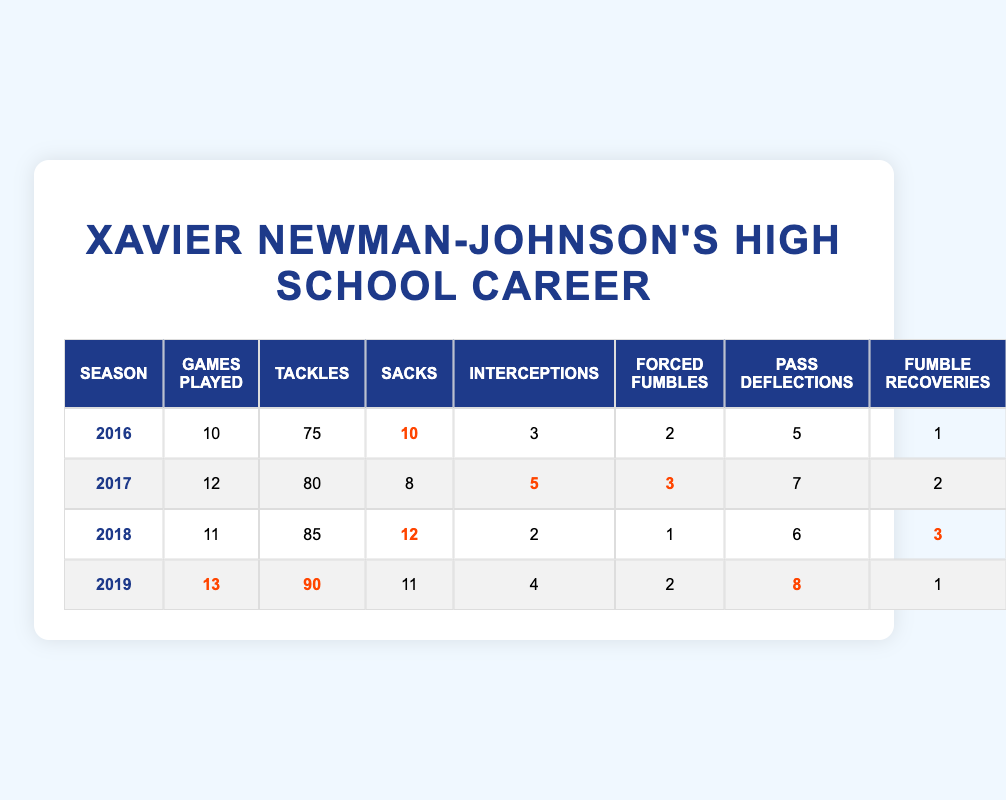What was Xavier Newman-Johnson's highest number of tackles in a season? In the table, we can see that the number of tackles varies by season. The highest value listed is 90 in the 2019 season.
Answer: 90 In which season did Xavier Newman-Johnson achieve the most sacks? By looking through the Sacks column, we note the maximum number is 12, which occurred during the 2018 season.
Answer: 2018 How many total interceptions did Xavier Newman-Johnson have over his high school career? To find the total interceptions, we add up the values from each season: 3 + 5 + 2 + 4 = 14.
Answer: 14 Did Xavier Newman-Johnson have more forced fumbles in 2017 compared to 2016? The data shows that he had 3 forced fumbles in 2017 and 2 in 2016. Therefore, he did have more in 2017.
Answer: Yes What was the average number of games played per season during Xavier Newman-Johnson's high school career? The total number of games played is 10 + 12 + 11 + 13 = 46. There are 4 seasons, so the average is 46 / 4 = 11.5.
Answer: 11.5 Which season had the highest number of fumble recoveries? In the Fumble Recoveries column, we can see the values are 1, 2, 3, and 1 for each respective season. The highest recorded is 3 in 2018.
Answer: 2018 How many more pass deflections did Xavier Newman-Johnson achieve in his best season compared to his worst? The best season for pass deflections was 8 in 2019, and the worst was 5 in 2016. The difference is 8 - 5 = 3.
Answer: 3 Was there a season where he had exactly the same number of fumble recoveries as forced fumbles? Checking the Fumble Recoveries (1, 2, 3, 1) against Forced Fumbles (2, 3, 1, 2), we see he had the same number in 2018, with 1 fumble recovery and 1 forced fumble.
Answer: Yes 